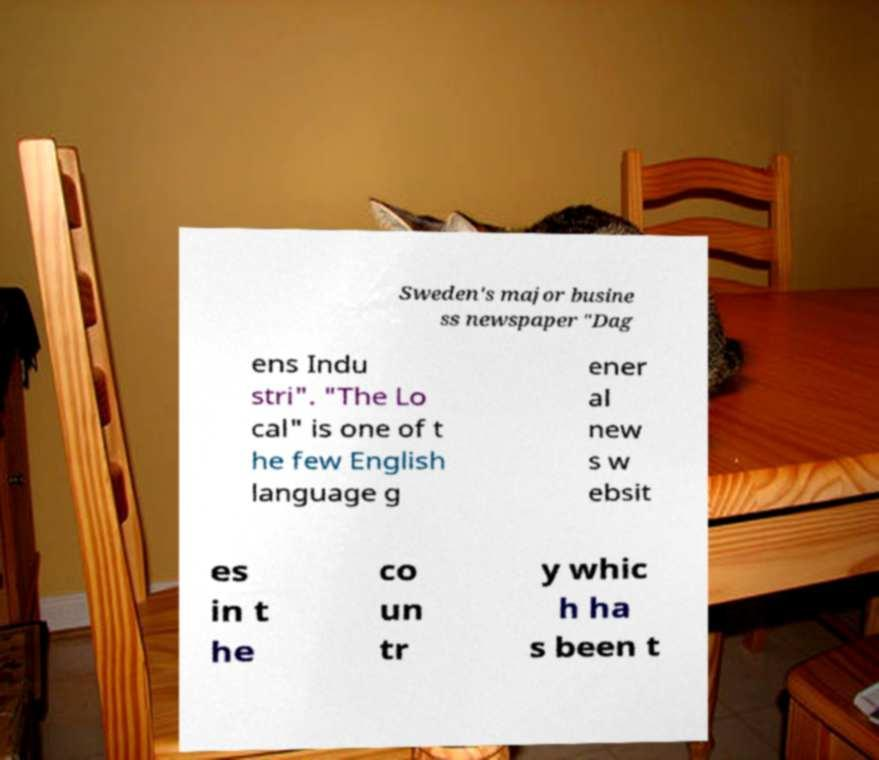What messages or text are displayed in this image? I need them in a readable, typed format. Sweden's major busine ss newspaper "Dag ens Indu stri". "The Lo cal" is one of t he few English language g ener al new s w ebsit es in t he co un tr y whic h ha s been t 